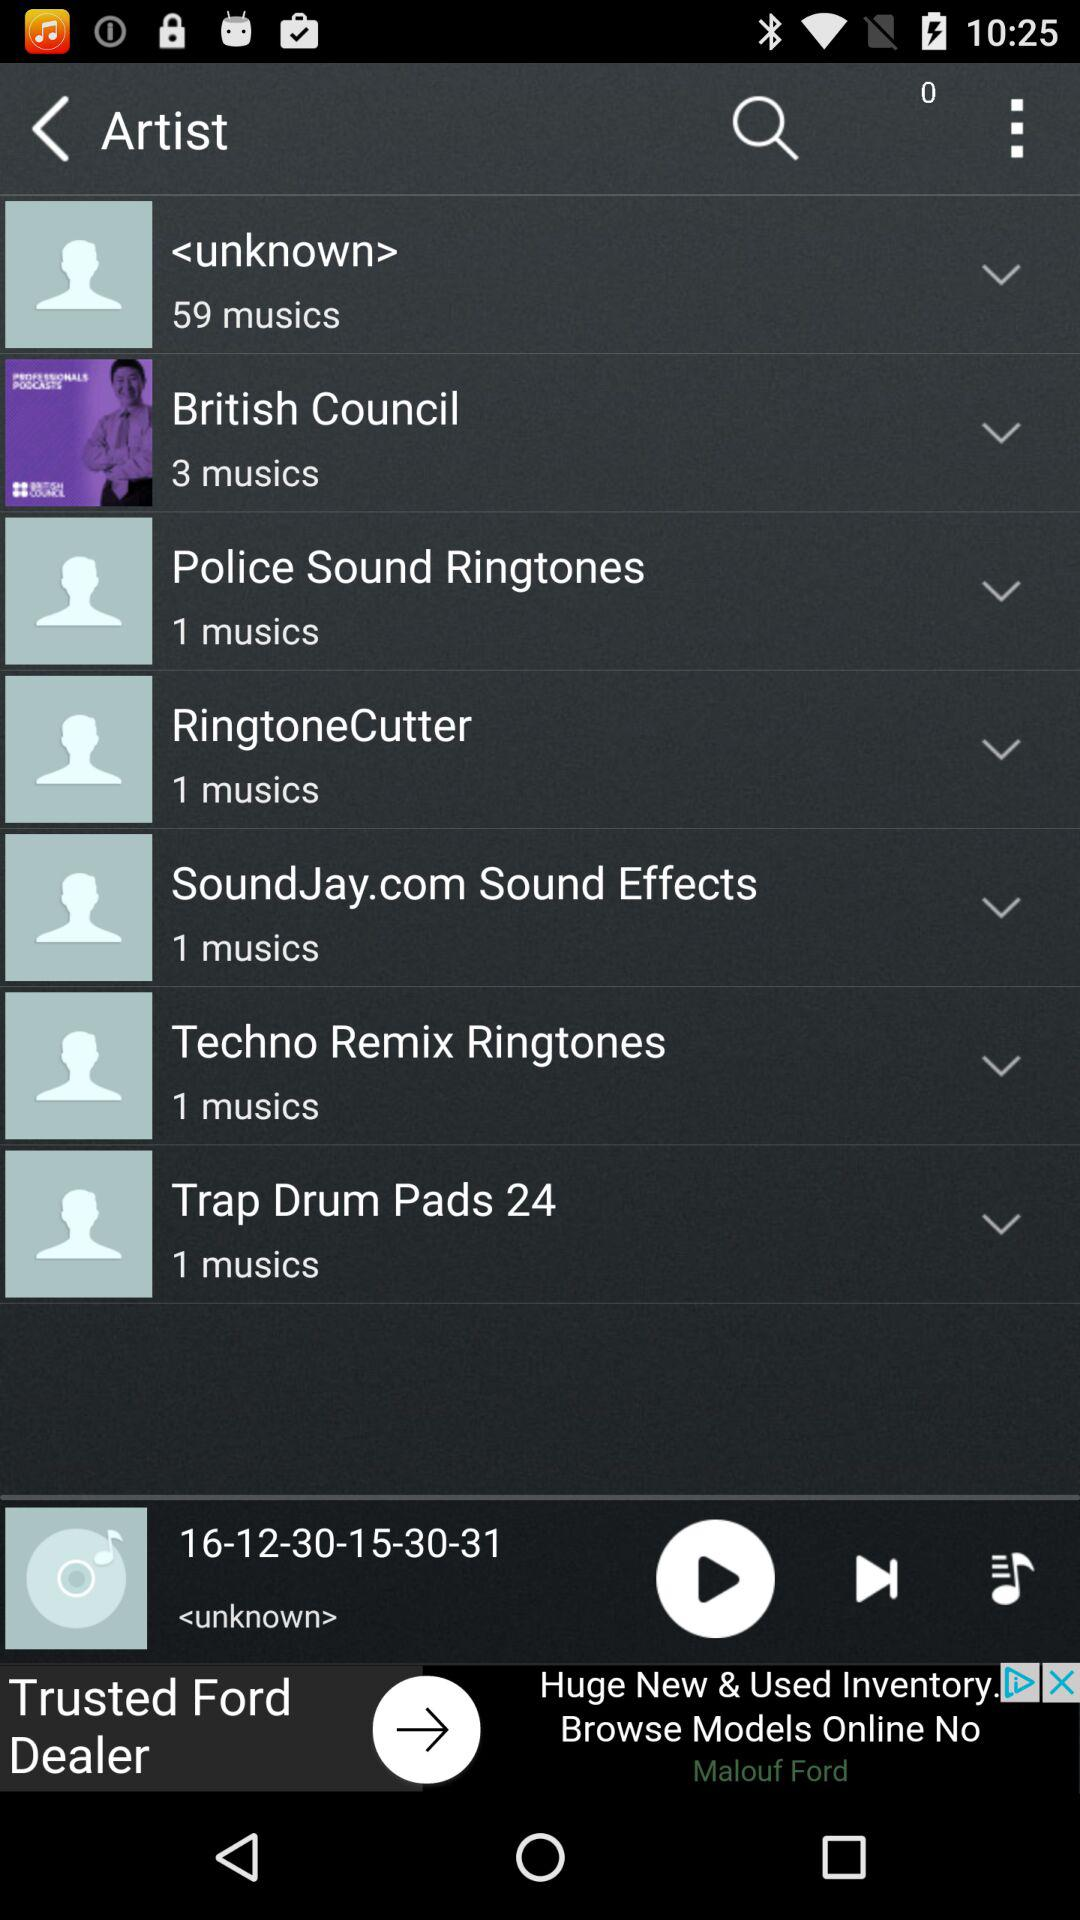What is the number of songs in "Trap Drum Pads 24"? The number of songs in "Trap Drum Pads 24" is 1. 